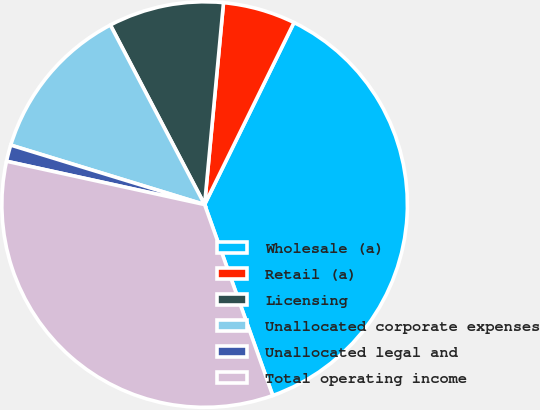Convert chart. <chart><loc_0><loc_0><loc_500><loc_500><pie_chart><fcel>Wholesale (a)<fcel>Retail (a)<fcel>Licensing<fcel>Unallocated corporate expenses<fcel>Unallocated legal and<fcel>Total operating income<nl><fcel>37.28%<fcel>5.78%<fcel>9.18%<fcel>12.57%<fcel>1.31%<fcel>33.88%<nl></chart> 